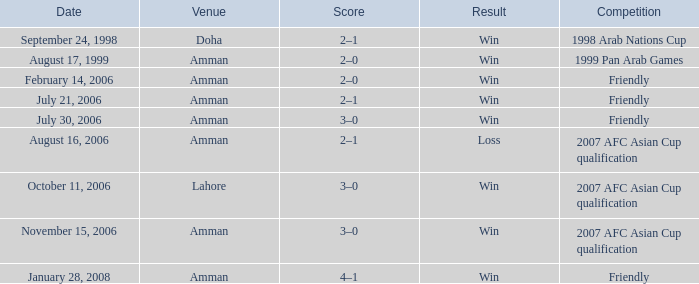At what venue did ra'fat ali perform on the 17th of august, 1999? Amman. Help me parse the entirety of this table. {'header': ['Date', 'Venue', 'Score', 'Result', 'Competition'], 'rows': [['September 24, 1998', 'Doha', '2–1', 'Win', '1998 Arab Nations Cup'], ['August 17, 1999', 'Amman', '2–0', 'Win', '1999 Pan Arab Games'], ['February 14, 2006', 'Amman', '2–0', 'Win', 'Friendly'], ['July 21, 2006', 'Amman', '2–1', 'Win', 'Friendly'], ['July 30, 2006', 'Amman', '3–0', 'Win', 'Friendly'], ['August 16, 2006', 'Amman', '2–1', 'Loss', '2007 AFC Asian Cup qualification'], ['October 11, 2006', 'Lahore', '3–0', 'Win', '2007 AFC Asian Cup qualification'], ['November 15, 2006', 'Amman', '3–0', 'Win', '2007 AFC Asian Cup qualification'], ['January 28, 2008', 'Amman', '4–1', 'Win', 'Friendly']]} 